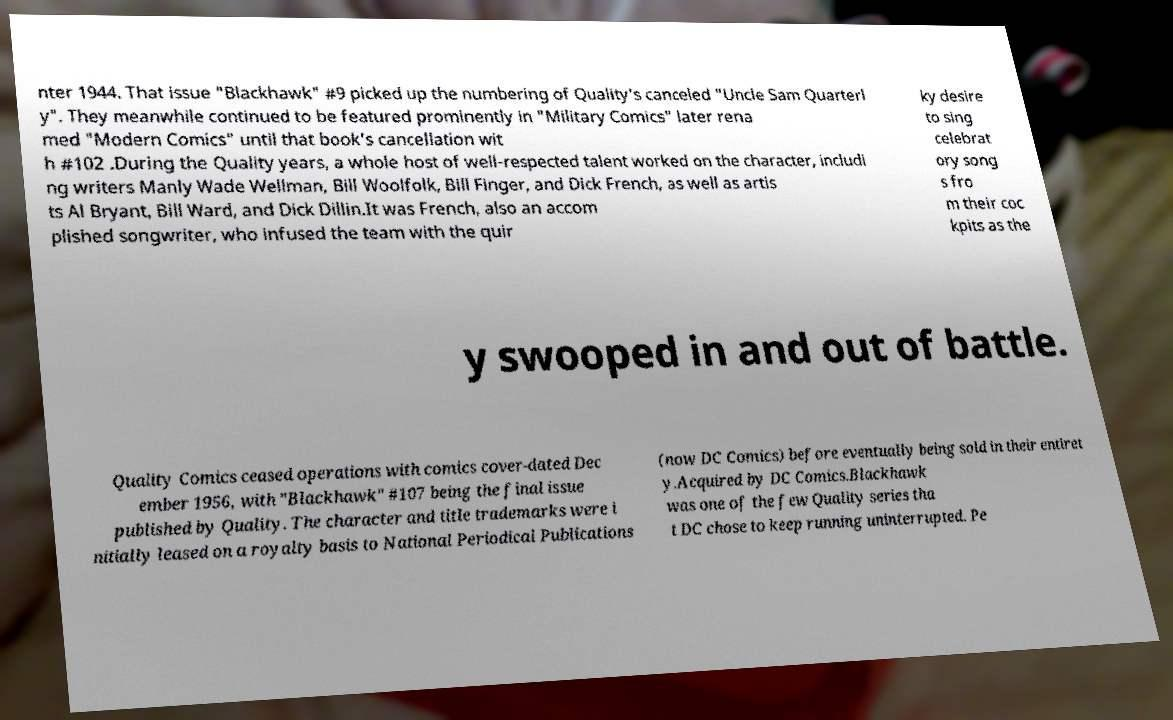I need the written content from this picture converted into text. Can you do that? nter 1944. That issue "Blackhawk" #9 picked up the numbering of Quality's canceled "Uncle Sam Quarterl y". They meanwhile continued to be featured prominently in "Military Comics" later rena med "Modern Comics" until that book's cancellation wit h #102 .During the Quality years, a whole host of well-respected talent worked on the character, includi ng writers Manly Wade Wellman, Bill Woolfolk, Bill Finger, and Dick French, as well as artis ts Al Bryant, Bill Ward, and Dick Dillin.It was French, also an accom plished songwriter, who infused the team with the quir ky desire to sing celebrat ory song s fro m their coc kpits as the y swooped in and out of battle. Quality Comics ceased operations with comics cover-dated Dec ember 1956, with "Blackhawk" #107 being the final issue published by Quality. The character and title trademarks were i nitially leased on a royalty basis to National Periodical Publications (now DC Comics) before eventually being sold in their entiret y.Acquired by DC Comics.Blackhawk was one of the few Quality series tha t DC chose to keep running uninterrupted. Pe 